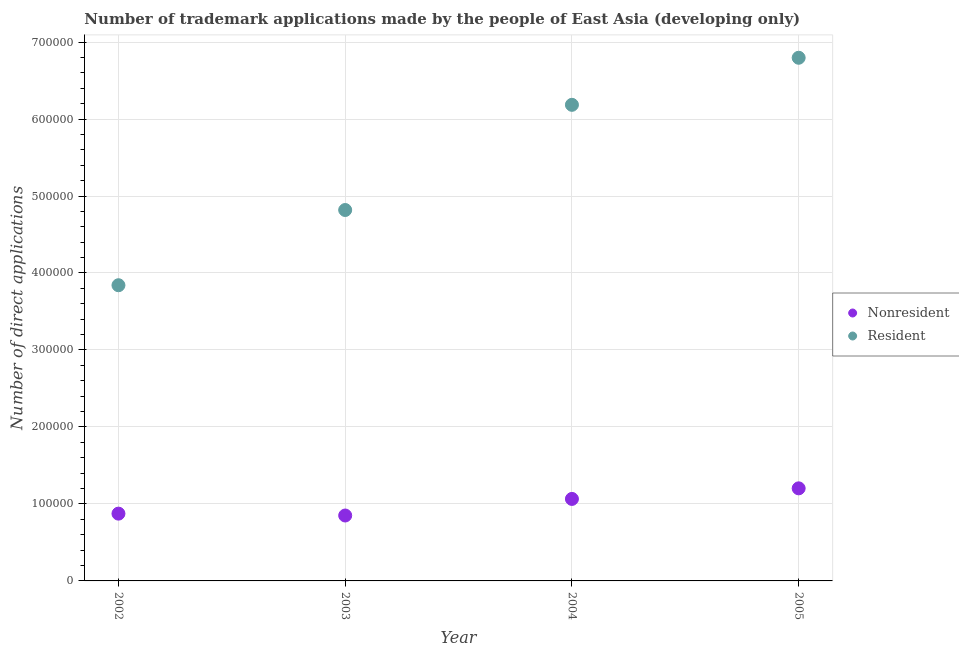What is the number of trademark applications made by non residents in 2003?
Give a very brief answer. 8.50e+04. Across all years, what is the maximum number of trademark applications made by residents?
Your response must be concise. 6.80e+05. Across all years, what is the minimum number of trademark applications made by residents?
Offer a terse response. 3.84e+05. What is the total number of trademark applications made by residents in the graph?
Your response must be concise. 2.16e+06. What is the difference between the number of trademark applications made by non residents in 2002 and that in 2004?
Provide a succinct answer. -1.91e+04. What is the difference between the number of trademark applications made by non residents in 2003 and the number of trademark applications made by residents in 2002?
Your answer should be compact. -2.99e+05. What is the average number of trademark applications made by residents per year?
Your response must be concise. 5.41e+05. In the year 2002, what is the difference between the number of trademark applications made by residents and number of trademark applications made by non residents?
Your answer should be compact. 2.97e+05. In how many years, is the number of trademark applications made by non residents greater than 20000?
Your response must be concise. 4. What is the ratio of the number of trademark applications made by non residents in 2003 to that in 2005?
Ensure brevity in your answer.  0.71. Is the number of trademark applications made by non residents in 2002 less than that in 2005?
Your response must be concise. Yes. What is the difference between the highest and the second highest number of trademark applications made by non residents?
Ensure brevity in your answer.  1.37e+04. What is the difference between the highest and the lowest number of trademark applications made by residents?
Provide a succinct answer. 2.95e+05. Is the sum of the number of trademark applications made by non residents in 2004 and 2005 greater than the maximum number of trademark applications made by residents across all years?
Provide a short and direct response. No. Does the number of trademark applications made by non residents monotonically increase over the years?
Your answer should be compact. No. Is the number of trademark applications made by residents strictly less than the number of trademark applications made by non residents over the years?
Your response must be concise. No. How many years are there in the graph?
Your answer should be compact. 4. What is the difference between two consecutive major ticks on the Y-axis?
Provide a succinct answer. 1.00e+05. Are the values on the major ticks of Y-axis written in scientific E-notation?
Give a very brief answer. No. Does the graph contain any zero values?
Your answer should be very brief. No. How many legend labels are there?
Provide a succinct answer. 2. What is the title of the graph?
Your answer should be very brief. Number of trademark applications made by the people of East Asia (developing only). What is the label or title of the X-axis?
Give a very brief answer. Year. What is the label or title of the Y-axis?
Your answer should be very brief. Number of direct applications. What is the Number of direct applications of Nonresident in 2002?
Your response must be concise. 8.74e+04. What is the Number of direct applications in Resident in 2002?
Make the answer very short. 3.84e+05. What is the Number of direct applications of Nonresident in 2003?
Provide a short and direct response. 8.50e+04. What is the Number of direct applications of Resident in 2003?
Offer a terse response. 4.82e+05. What is the Number of direct applications in Nonresident in 2004?
Your answer should be compact. 1.07e+05. What is the Number of direct applications of Resident in 2004?
Offer a terse response. 6.18e+05. What is the Number of direct applications of Nonresident in 2005?
Make the answer very short. 1.20e+05. What is the Number of direct applications of Resident in 2005?
Your response must be concise. 6.80e+05. Across all years, what is the maximum Number of direct applications of Nonresident?
Your answer should be very brief. 1.20e+05. Across all years, what is the maximum Number of direct applications of Resident?
Make the answer very short. 6.80e+05. Across all years, what is the minimum Number of direct applications in Nonresident?
Offer a very short reply. 8.50e+04. Across all years, what is the minimum Number of direct applications of Resident?
Offer a very short reply. 3.84e+05. What is the total Number of direct applications of Nonresident in the graph?
Your answer should be compact. 3.99e+05. What is the total Number of direct applications of Resident in the graph?
Your response must be concise. 2.16e+06. What is the difference between the Number of direct applications in Nonresident in 2002 and that in 2003?
Provide a short and direct response. 2428. What is the difference between the Number of direct applications of Resident in 2002 and that in 2003?
Offer a terse response. -9.77e+04. What is the difference between the Number of direct applications of Nonresident in 2002 and that in 2004?
Provide a short and direct response. -1.91e+04. What is the difference between the Number of direct applications in Resident in 2002 and that in 2004?
Provide a succinct answer. -2.34e+05. What is the difference between the Number of direct applications of Nonresident in 2002 and that in 2005?
Provide a succinct answer. -3.29e+04. What is the difference between the Number of direct applications of Resident in 2002 and that in 2005?
Offer a very short reply. -2.95e+05. What is the difference between the Number of direct applications in Nonresident in 2003 and that in 2004?
Provide a short and direct response. -2.15e+04. What is the difference between the Number of direct applications in Resident in 2003 and that in 2004?
Offer a terse response. -1.37e+05. What is the difference between the Number of direct applications in Nonresident in 2003 and that in 2005?
Offer a very short reply. -3.53e+04. What is the difference between the Number of direct applications in Resident in 2003 and that in 2005?
Your answer should be very brief. -1.98e+05. What is the difference between the Number of direct applications in Nonresident in 2004 and that in 2005?
Provide a short and direct response. -1.37e+04. What is the difference between the Number of direct applications of Resident in 2004 and that in 2005?
Provide a short and direct response. -6.11e+04. What is the difference between the Number of direct applications of Nonresident in 2002 and the Number of direct applications of Resident in 2003?
Keep it short and to the point. -3.94e+05. What is the difference between the Number of direct applications in Nonresident in 2002 and the Number of direct applications in Resident in 2004?
Your answer should be compact. -5.31e+05. What is the difference between the Number of direct applications in Nonresident in 2002 and the Number of direct applications in Resident in 2005?
Ensure brevity in your answer.  -5.92e+05. What is the difference between the Number of direct applications in Nonresident in 2003 and the Number of direct applications in Resident in 2004?
Your response must be concise. -5.33e+05. What is the difference between the Number of direct applications of Nonresident in 2003 and the Number of direct applications of Resident in 2005?
Your answer should be compact. -5.95e+05. What is the difference between the Number of direct applications of Nonresident in 2004 and the Number of direct applications of Resident in 2005?
Provide a succinct answer. -5.73e+05. What is the average Number of direct applications in Nonresident per year?
Ensure brevity in your answer.  9.98e+04. What is the average Number of direct applications of Resident per year?
Keep it short and to the point. 5.41e+05. In the year 2002, what is the difference between the Number of direct applications in Nonresident and Number of direct applications in Resident?
Provide a short and direct response. -2.97e+05. In the year 2003, what is the difference between the Number of direct applications of Nonresident and Number of direct applications of Resident?
Your answer should be very brief. -3.97e+05. In the year 2004, what is the difference between the Number of direct applications in Nonresident and Number of direct applications in Resident?
Your response must be concise. -5.12e+05. In the year 2005, what is the difference between the Number of direct applications in Nonresident and Number of direct applications in Resident?
Keep it short and to the point. -5.59e+05. What is the ratio of the Number of direct applications of Nonresident in 2002 to that in 2003?
Ensure brevity in your answer.  1.03. What is the ratio of the Number of direct applications of Resident in 2002 to that in 2003?
Your response must be concise. 0.8. What is the ratio of the Number of direct applications in Nonresident in 2002 to that in 2004?
Give a very brief answer. 0.82. What is the ratio of the Number of direct applications of Resident in 2002 to that in 2004?
Ensure brevity in your answer.  0.62. What is the ratio of the Number of direct applications of Nonresident in 2002 to that in 2005?
Ensure brevity in your answer.  0.73. What is the ratio of the Number of direct applications of Resident in 2002 to that in 2005?
Give a very brief answer. 0.57. What is the ratio of the Number of direct applications of Nonresident in 2003 to that in 2004?
Offer a terse response. 0.8. What is the ratio of the Number of direct applications in Resident in 2003 to that in 2004?
Your response must be concise. 0.78. What is the ratio of the Number of direct applications of Nonresident in 2003 to that in 2005?
Your answer should be very brief. 0.71. What is the ratio of the Number of direct applications of Resident in 2003 to that in 2005?
Provide a short and direct response. 0.71. What is the ratio of the Number of direct applications in Nonresident in 2004 to that in 2005?
Make the answer very short. 0.89. What is the ratio of the Number of direct applications in Resident in 2004 to that in 2005?
Your answer should be very brief. 0.91. What is the difference between the highest and the second highest Number of direct applications in Nonresident?
Ensure brevity in your answer.  1.37e+04. What is the difference between the highest and the second highest Number of direct applications in Resident?
Provide a succinct answer. 6.11e+04. What is the difference between the highest and the lowest Number of direct applications in Nonresident?
Your answer should be compact. 3.53e+04. What is the difference between the highest and the lowest Number of direct applications of Resident?
Offer a very short reply. 2.95e+05. 